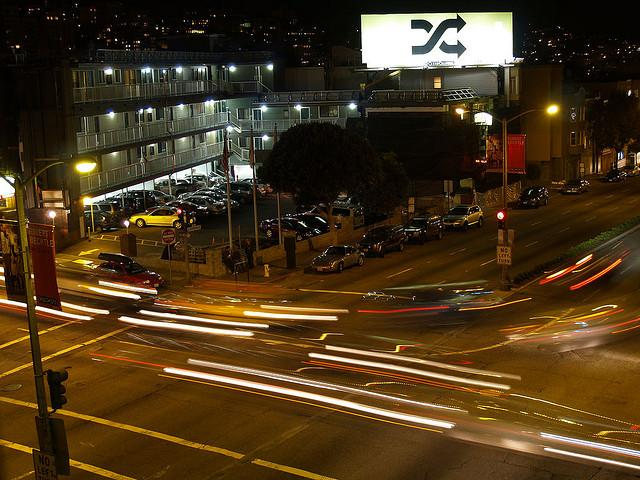What creates the colorful patterns on the ground?

Choices:
A) traffic
B) painting
C) thunder
D) street lamps traffic 